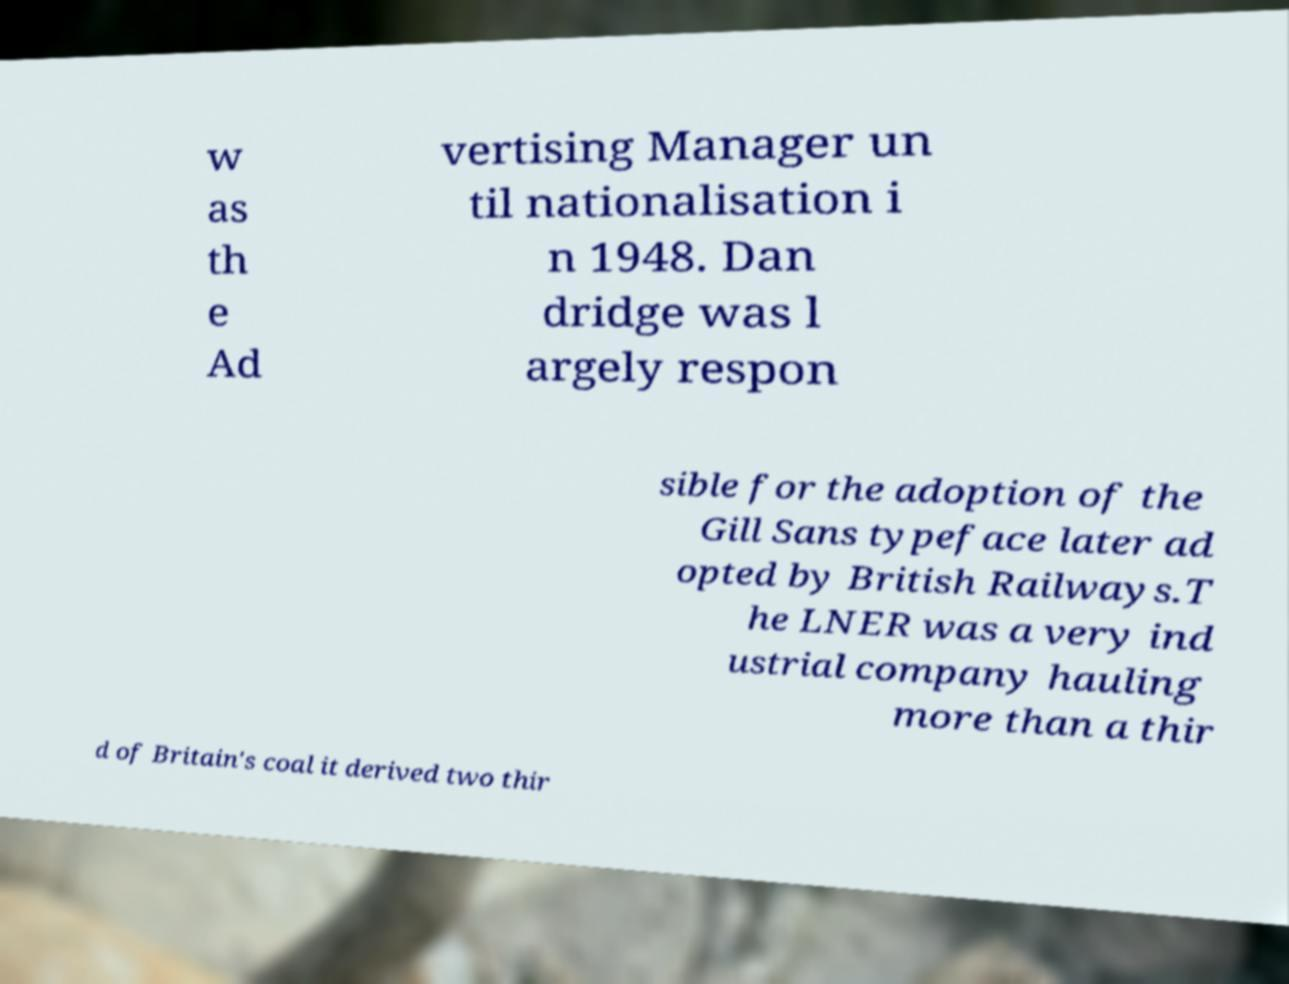What messages or text are displayed in this image? I need them in a readable, typed format. w as th e Ad vertising Manager un til nationalisation i n 1948. Dan dridge was l argely respon sible for the adoption of the Gill Sans typeface later ad opted by British Railways.T he LNER was a very ind ustrial company hauling more than a thir d of Britain's coal it derived two thir 